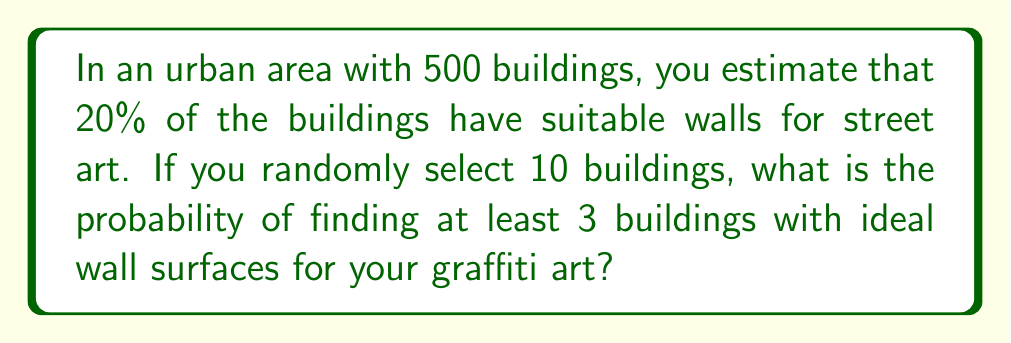Solve this math problem. Let's approach this step-by-step:

1) This scenario follows a binomial distribution. We need to find:

   $P(X \geq 3)$, where $X$ is the number of suitable buildings.

2) The parameters for our binomial distribution are:
   $n = 10$ (number of trials)
   $p = 0.20$ (probability of success on each trial)

3) We can calculate this as:

   $P(X \geq 3) = 1 - P(X < 3) = 1 - [P(X=0) + P(X=1) + P(X=2)]$

4) The probability mass function for a binomial distribution is:

   $P(X=k) = \binom{n}{k} p^k (1-p)^{n-k}$

5) Let's calculate each term:

   $P(X=0) = \binom{10}{0} (0.2)^0 (0.8)^{10} = 0.1074$
   
   $P(X=1) = \binom{10}{1} (0.2)^1 (0.8)^9 = 0.2684$
   
   $P(X=2) = \binom{10}{2} (0.2)^2 (0.8)^8 = 0.3020$

6) Now we can sum these up and subtract from 1:

   $P(X \geq 3) = 1 - (0.1074 + 0.2684 + 0.3020) = 1 - 0.6778 = 0.3222$

7) Therefore, the probability of finding at least 3 suitable buildings out of 10 randomly selected buildings is approximately 0.3222 or 32.22%.
Answer: 0.3222 